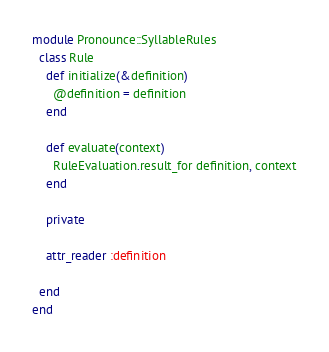Convert code to text. <code><loc_0><loc_0><loc_500><loc_500><_Ruby_>
module Pronounce::SyllableRules
  class Rule
    def initialize(&definition)
      @definition = definition
    end

    def evaluate(context)
      RuleEvaluation.result_for definition, context
    end

    private

    attr_reader :definition

  end
end
</code> 